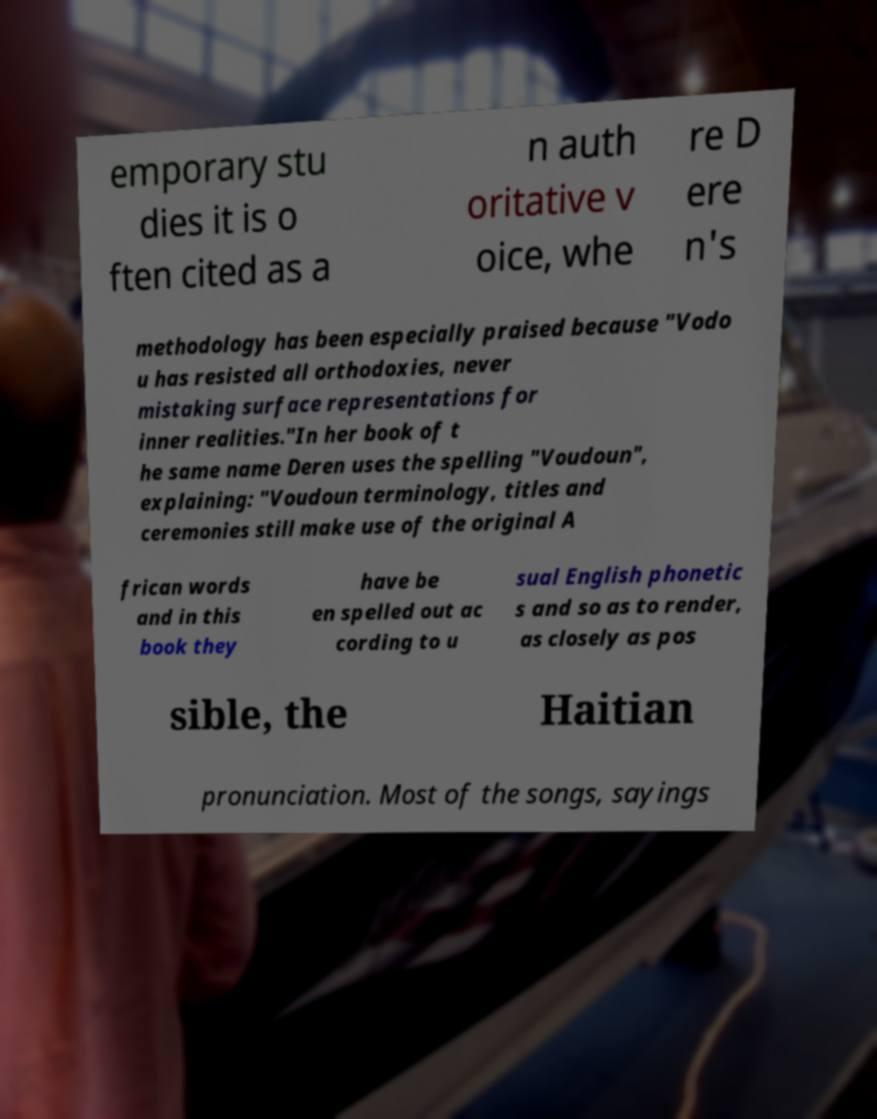What messages or text are displayed in this image? I need them in a readable, typed format. emporary stu dies it is o ften cited as a n auth oritative v oice, whe re D ere n's methodology has been especially praised because "Vodo u has resisted all orthodoxies, never mistaking surface representations for inner realities."In her book of t he same name Deren uses the spelling "Voudoun", explaining: "Voudoun terminology, titles and ceremonies still make use of the original A frican words and in this book they have be en spelled out ac cording to u sual English phonetic s and so as to render, as closely as pos sible, the Haitian pronunciation. Most of the songs, sayings 